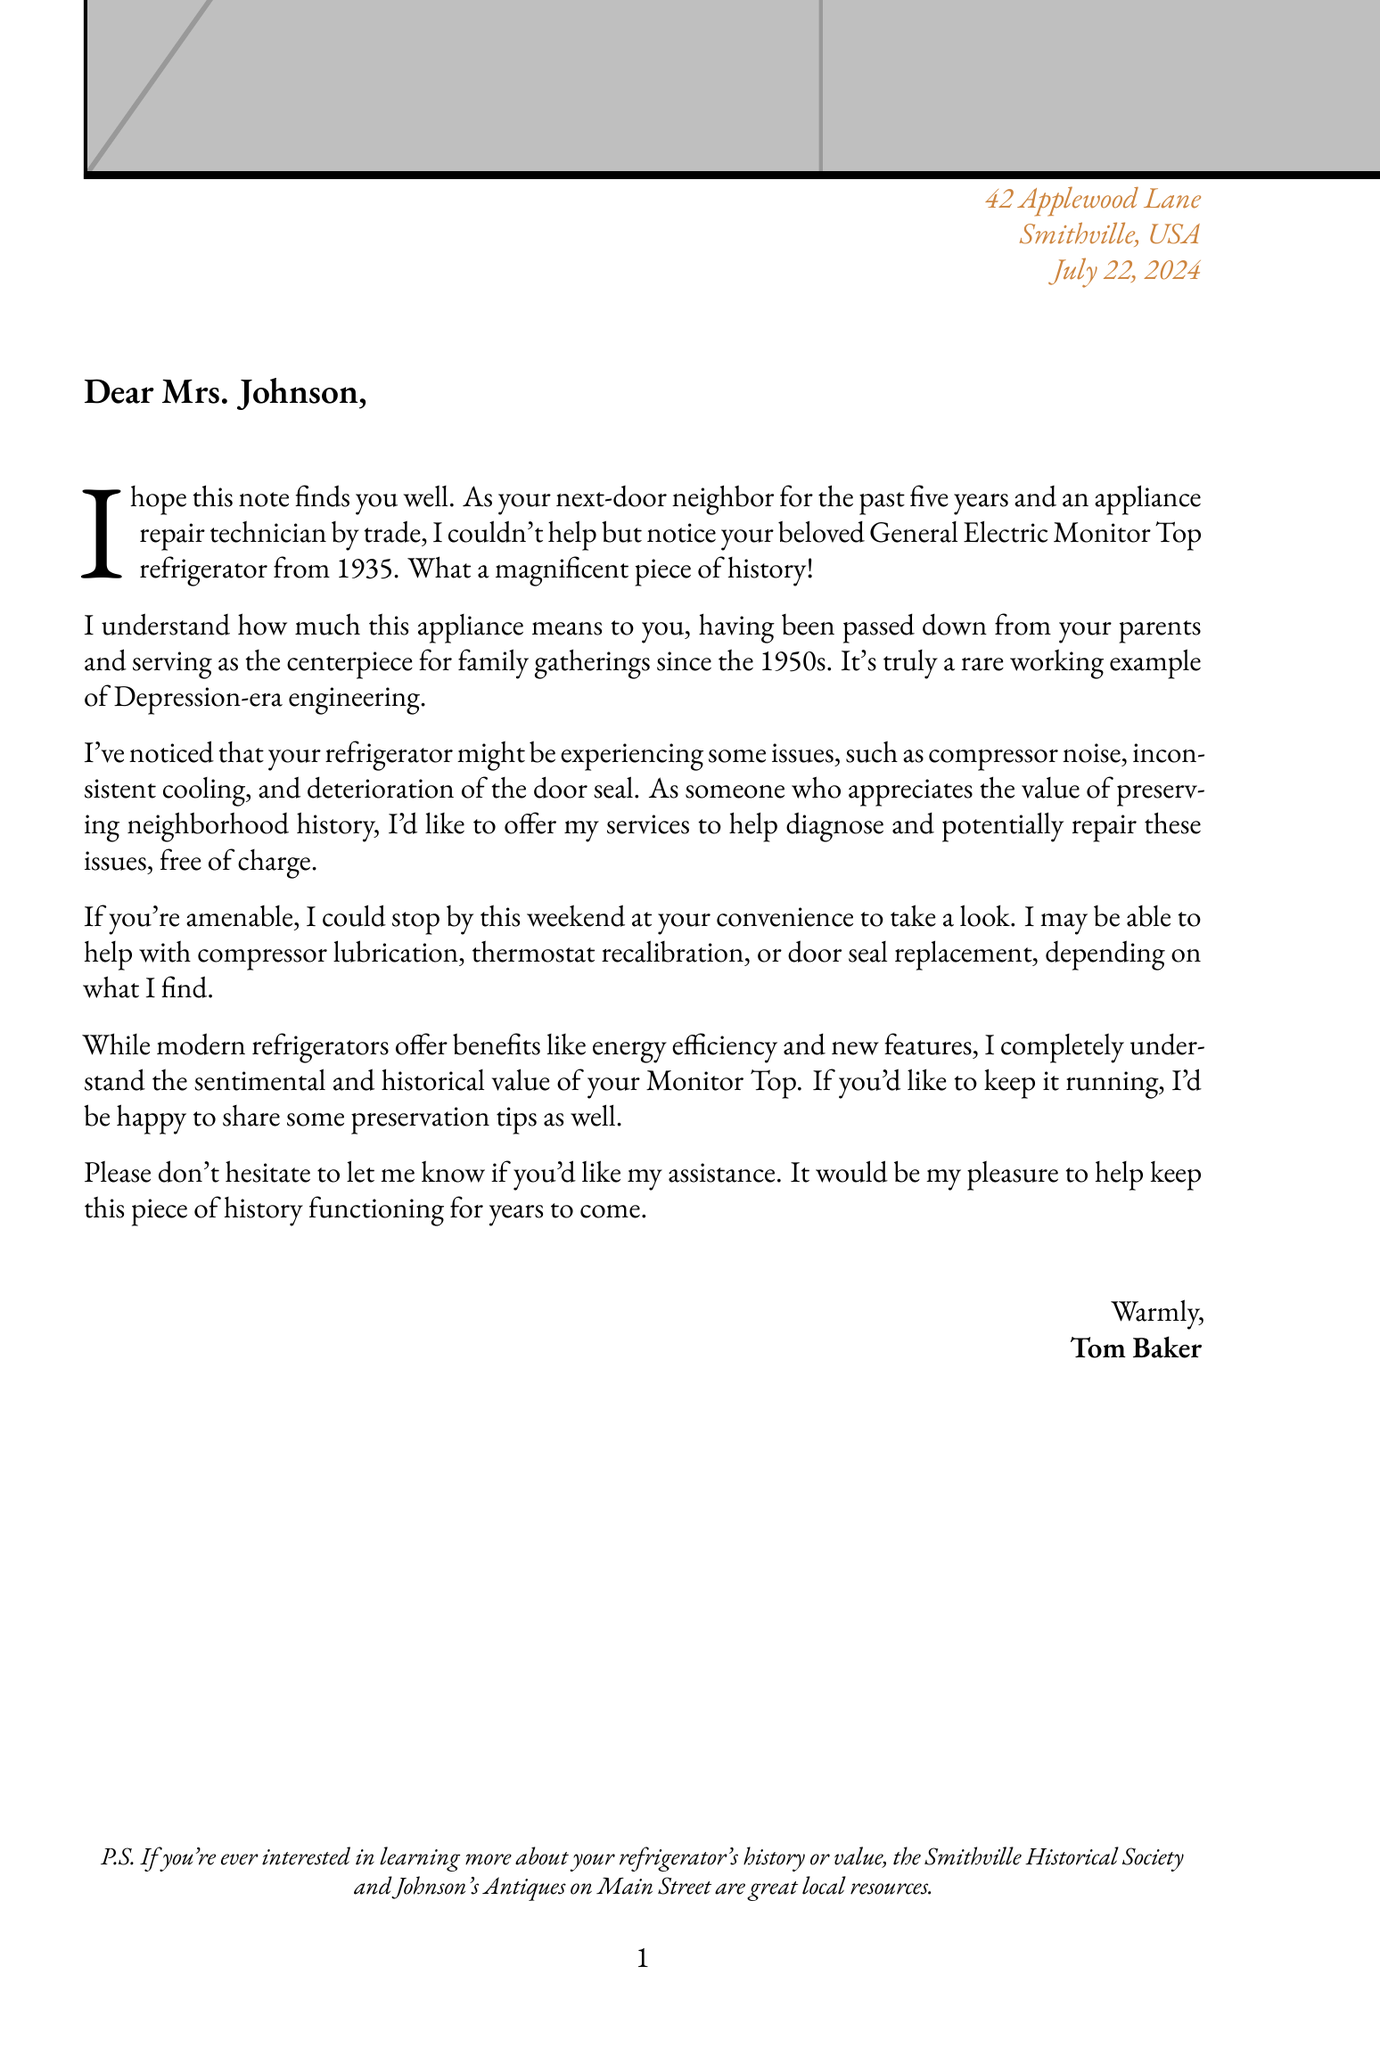What is the name of the neighbor? The letter specifies that the neighbor's name is Tom Baker.
Answer: Tom Baker What model is the refrigerator? The document states the refrigerator model is the Monitor Top.
Answer: Monitor Top What year was the refrigerator manufactured? According to the letter, the refrigerator was manufactured in the year 1935.
Answer: 1935 What is one of the known issues with the refrigerator? The document lists compressor noise as one of the known issues.
Answer: Compressor noise What service is Tom offering? The letter mentions a free diagnosis and repair attempt for the refrigerator.
Answer: Free diagnosis and repair attempt What is one of the possible solutions mentioned for the refrigerator issue? The letter suggests thermostat recalibration as a possible solution.
Answer: Thermostat recalibration How long has Tom been the neighbor? The document states that Tom has been the neighbor for 5 years.
Answer: 5 years What is the motivation behind Tom's offer? The letter indicates that Tom's motivation is preserving neighborhood history and helping a friend.
Answer: Preserving neighborhood history and helping a friend What is one preservation tip provided in the letter? The letter offers regular cleaning of condenser coils as a preservation tip.
Answer: Regular cleaning of condenser coils 